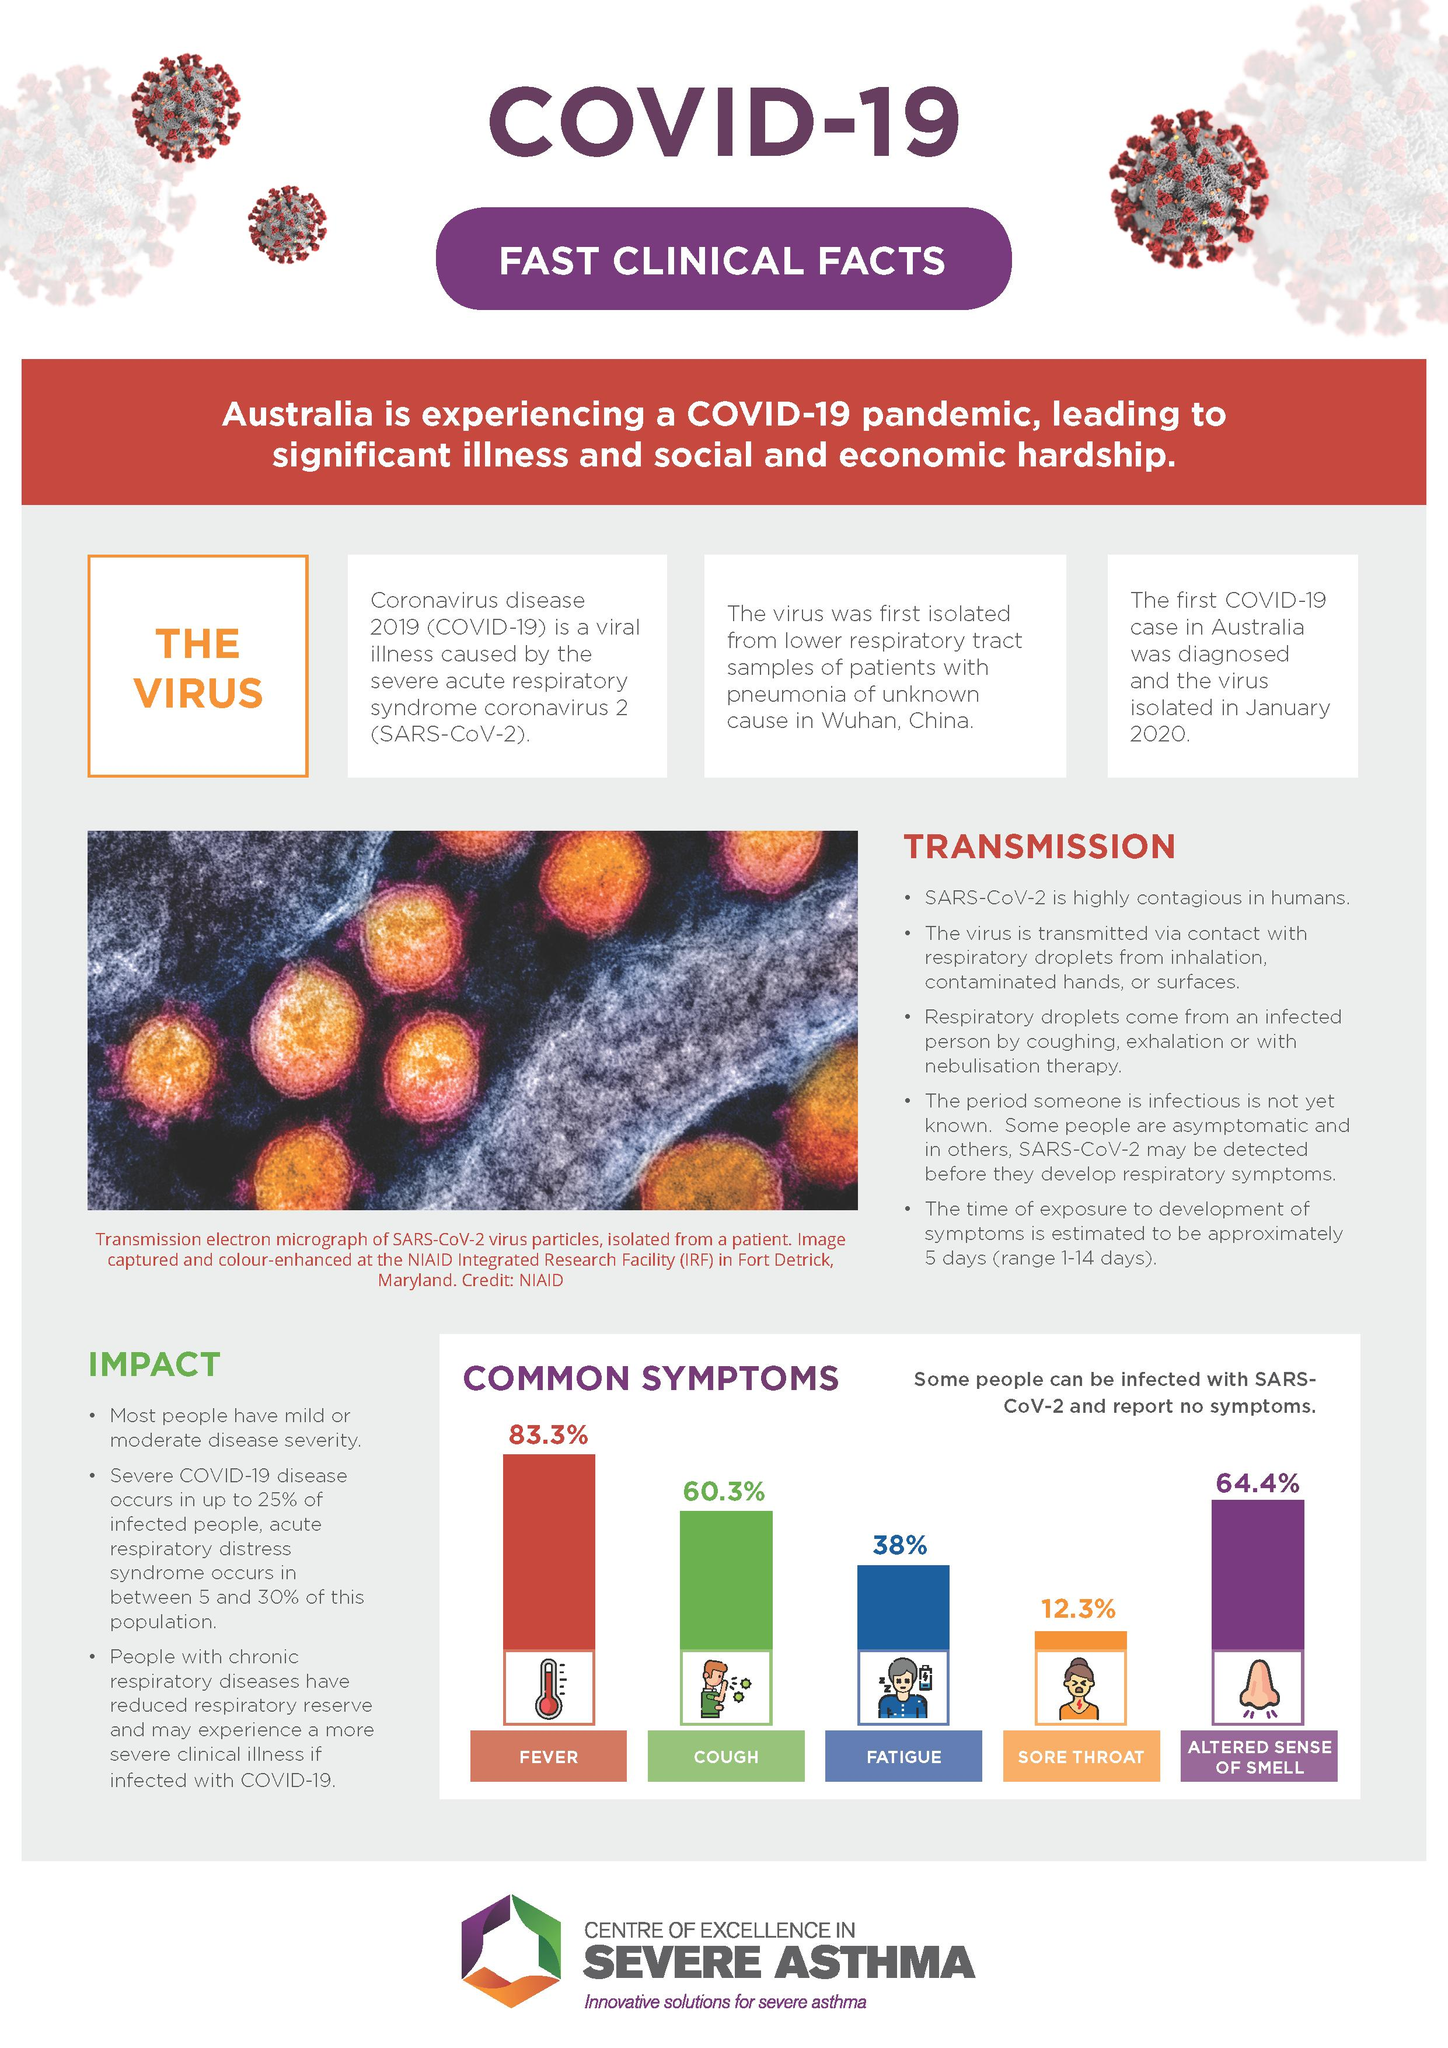Highlight a few significant elements in this photo. The most common symptom shown by infected individuals is an altered sense of smell, while cough may also be present. A majority of infected individuals exhibit common symptoms such as fever. The coronavirus was first isolated in China. Sore throat is the least common symptom among infected patients, Sore throat is one of the common symptoms that is exhibited by less than 40% of the infected individuals. 